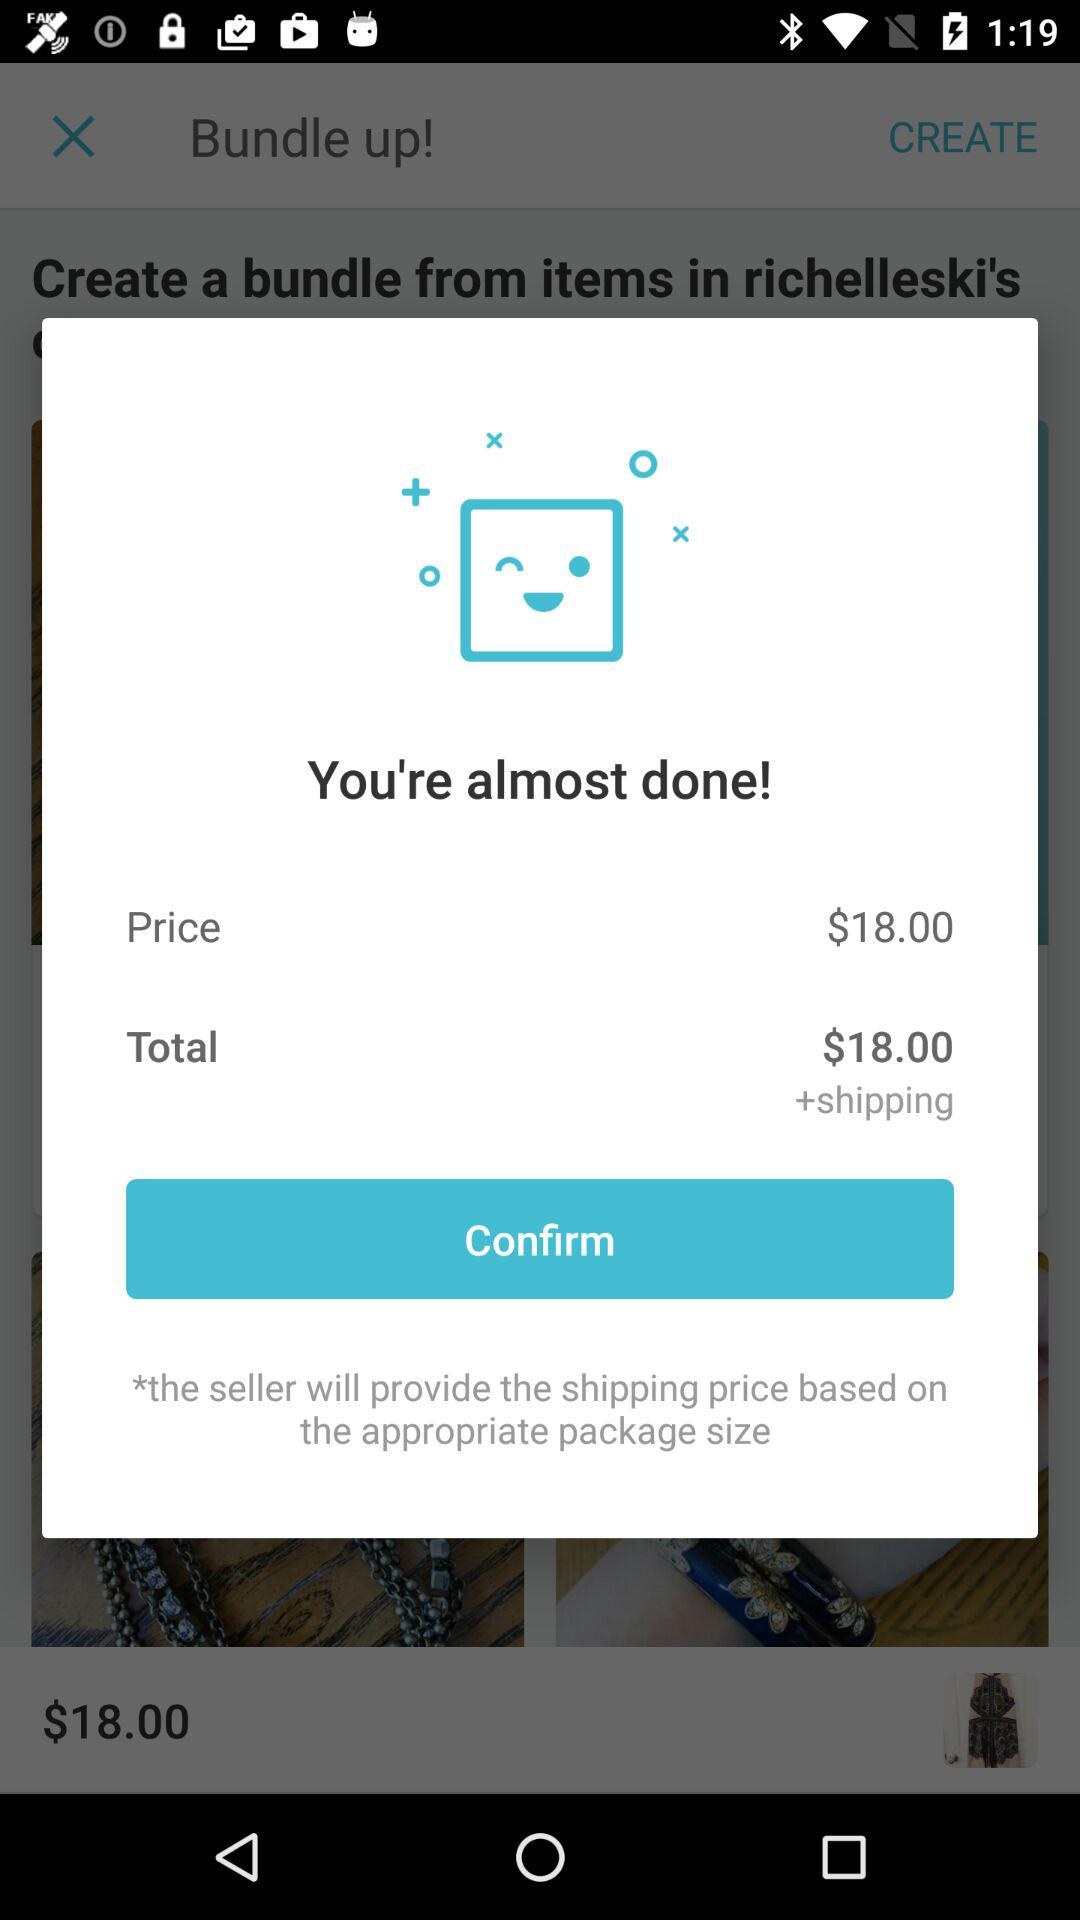What's the total price? The total price is $18.00. 